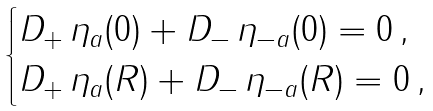<formula> <loc_0><loc_0><loc_500><loc_500>\begin{cases} D _ { + } \, \eta _ { a } ( 0 ) + D _ { - } \, \eta _ { - a } ( 0 ) = 0 \, , \\ D _ { + } \, \eta _ { a } ( R ) + D _ { - } \, \eta _ { - a } ( R ) = 0 \, , \end{cases}</formula> 